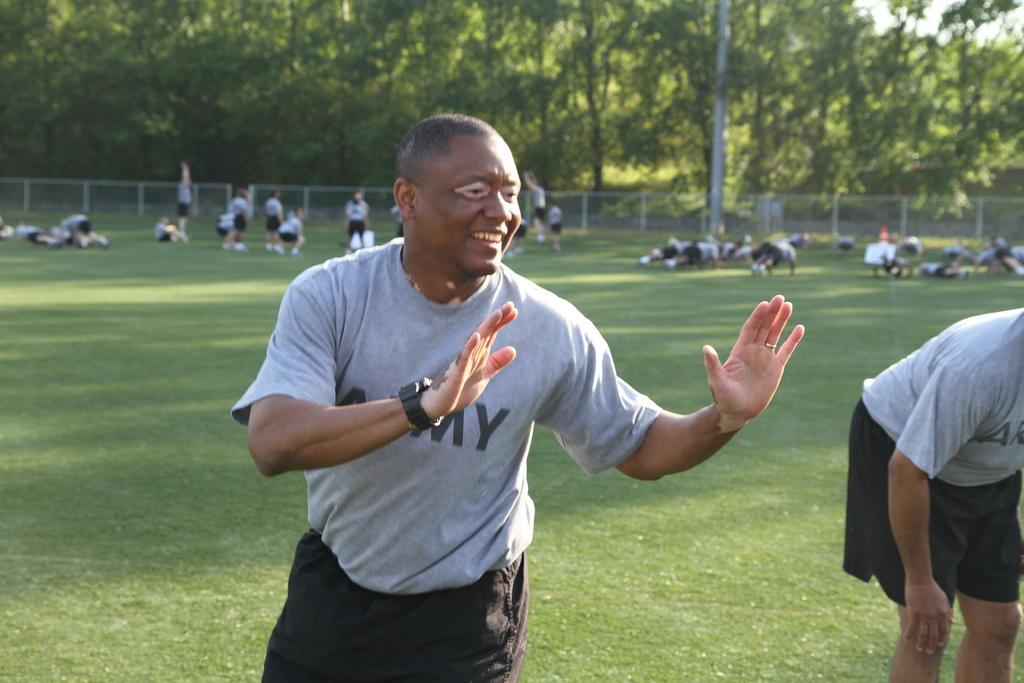Please provide a concise description of this image. In this image in the foreground there are two persons and in the background there are some people who are doing exercises and also there are some trees, net and pole. At the bottom there is grass. 